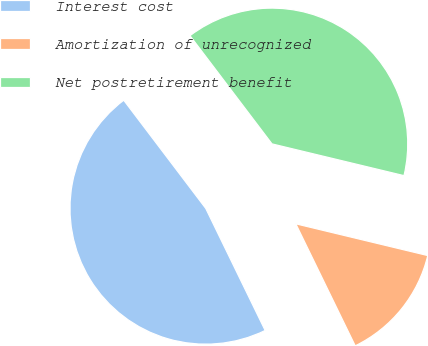<chart> <loc_0><loc_0><loc_500><loc_500><pie_chart><fcel>Interest cost<fcel>Amortization of unrecognized<fcel>Net postretirement benefit<nl><fcel>46.89%<fcel>14.03%<fcel>39.08%<nl></chart> 